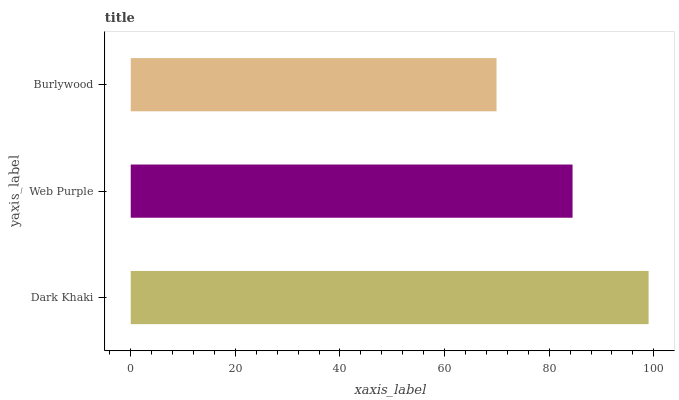Is Burlywood the minimum?
Answer yes or no. Yes. Is Dark Khaki the maximum?
Answer yes or no. Yes. Is Web Purple the minimum?
Answer yes or no. No. Is Web Purple the maximum?
Answer yes or no. No. Is Dark Khaki greater than Web Purple?
Answer yes or no. Yes. Is Web Purple less than Dark Khaki?
Answer yes or no. Yes. Is Web Purple greater than Dark Khaki?
Answer yes or no. No. Is Dark Khaki less than Web Purple?
Answer yes or no. No. Is Web Purple the high median?
Answer yes or no. Yes. Is Web Purple the low median?
Answer yes or no. Yes. Is Burlywood the high median?
Answer yes or no. No. Is Burlywood the low median?
Answer yes or no. No. 